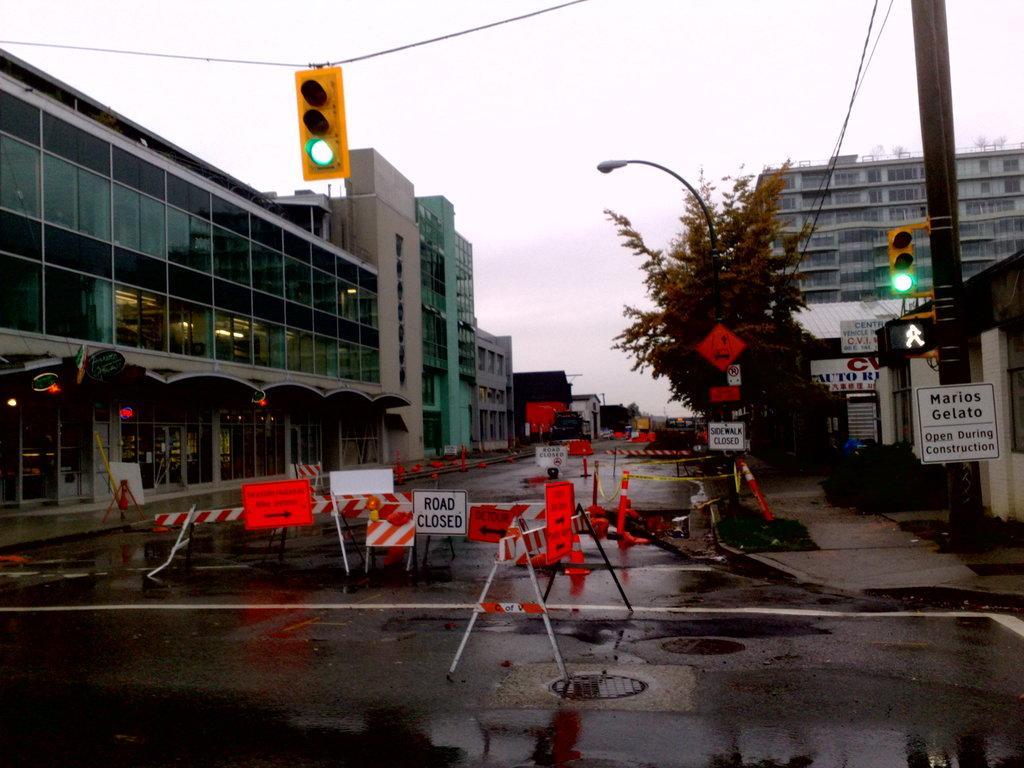Can you describe this image briefly? In this image there are buildings on the either side of the road, also there is a traffic lights on the rope under that there are some caution ropes and other things. 